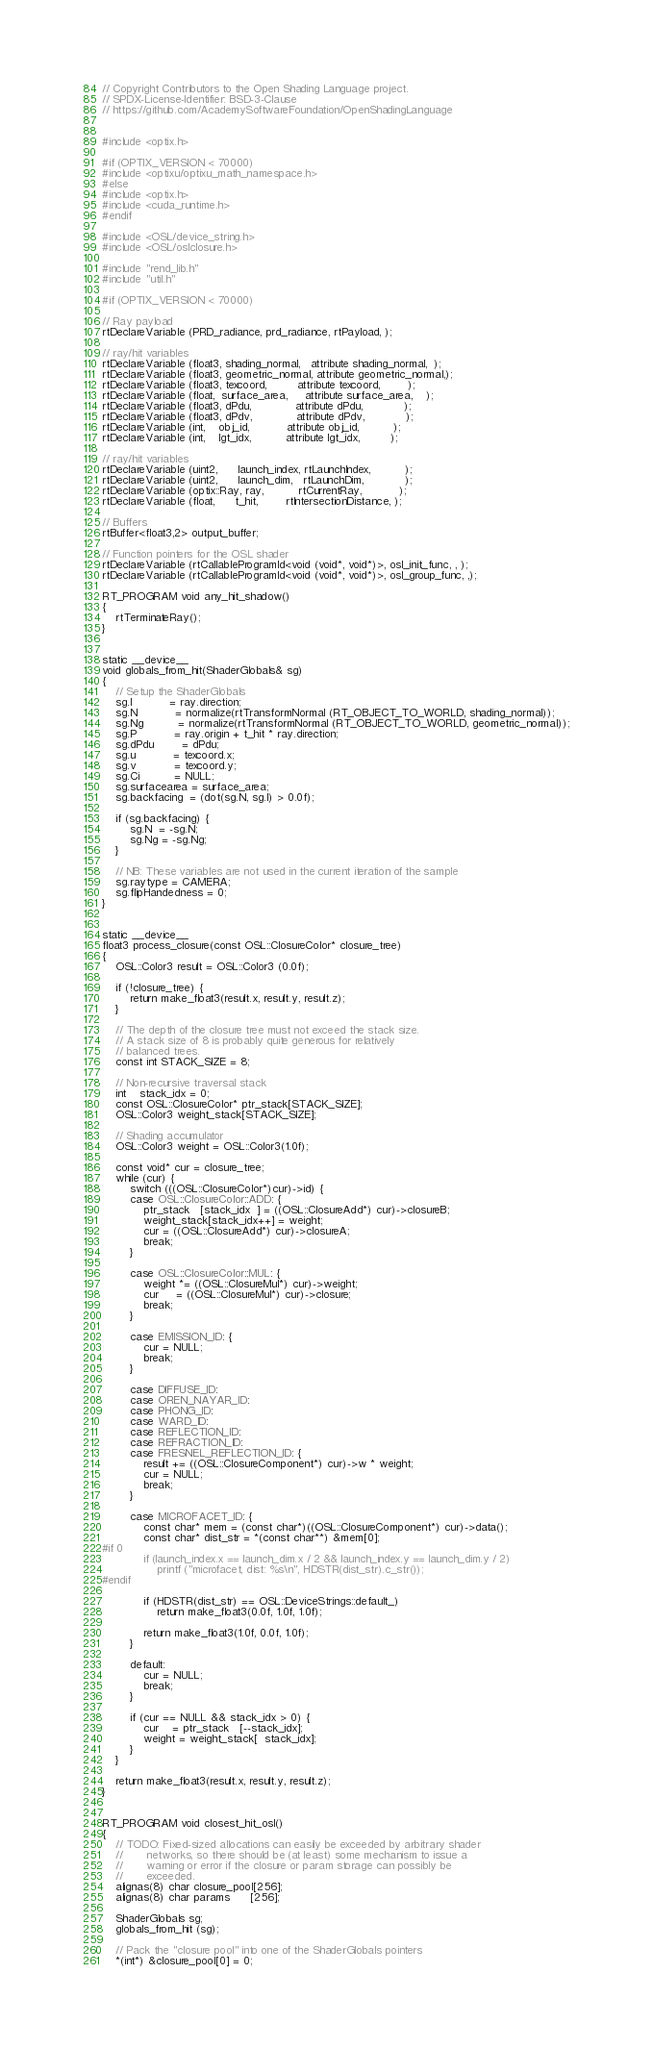<code> <loc_0><loc_0><loc_500><loc_500><_Cuda_>// Copyright Contributors to the Open Shading Language project.
// SPDX-License-Identifier: BSD-3-Clause
// https://github.com/AcademySoftwareFoundation/OpenShadingLanguage


#include <optix.h>

#if (OPTIX_VERSION < 70000) 
#include <optixu/optixu_math_namespace.h>
#else
#include <optix.h>
#include <cuda_runtime.h>
#endif

#include <OSL/device_string.h>
#include <OSL/oslclosure.h>

#include "rend_lib.h"
#include "util.h"

#if (OPTIX_VERSION < 70000)

// Ray payload
rtDeclareVariable (PRD_radiance, prd_radiance, rtPayload, );

// ray/hit variables
rtDeclareVariable (float3, shading_normal,   attribute shading_normal,  );
rtDeclareVariable (float3, geometric_normal, attribute geometric_normal,);
rtDeclareVariable (float3, texcoord,         attribute texcoord,        );
rtDeclareVariable (float,  surface_area,     attribute surface_area,    );
rtDeclareVariable (float3, dPdu,             attribute dPdu,            );
rtDeclareVariable (float3, dPdv,             attribute dPdv,            );
rtDeclareVariable (int,    obj_id,           attribute obj_id,          );
rtDeclareVariable (int,    lgt_idx,          attribute lgt_idx,         );

// ray/hit variables
rtDeclareVariable (uint2,      launch_index, rtLaunchIndex,          );
rtDeclareVariable (uint2,      launch_dim,   rtLaunchDim,            );
rtDeclareVariable (optix::Ray, ray,          rtCurrentRay,           );
rtDeclareVariable (float,      t_hit,        rtIntersectionDistance, );

// Buffers
rtBuffer<float3,2> output_buffer;

// Function pointers for the OSL shader
rtDeclareVariable (rtCallableProgramId<void (void*, void*)>, osl_init_func, , );
rtDeclareVariable (rtCallableProgramId<void (void*, void*)>, osl_group_func, ,);

RT_PROGRAM void any_hit_shadow()
{
    rtTerminateRay();
}


static __device__
void globals_from_hit(ShaderGlobals& sg)
{
    // Setup the ShaderGlobals
    sg.I           = ray.direction;
    sg.N           = normalize(rtTransformNormal (RT_OBJECT_TO_WORLD, shading_normal));
    sg.Ng          = normalize(rtTransformNormal (RT_OBJECT_TO_WORLD, geometric_normal));
    sg.P           = ray.origin + t_hit * ray.direction;
    sg.dPdu        = dPdu;
    sg.u           = texcoord.x;
    sg.v           = texcoord.y;
    sg.Ci          = NULL;
    sg.surfacearea = surface_area;
    sg.backfacing  = (dot(sg.N, sg.I) > 0.0f);

    if (sg.backfacing) {
        sg.N  = -sg.N;
        sg.Ng = -sg.Ng;
    }

    // NB: These variables are not used in the current iteration of the sample
    sg.raytype = CAMERA;
    sg.flipHandedness = 0;
}


static __device__
float3 process_closure(const OSL::ClosureColor* closure_tree)
{
    OSL::Color3 result = OSL::Color3 (0.0f);

    if (!closure_tree) {
        return make_float3(result.x, result.y, result.z);
    }

    // The depth of the closure tree must not exceed the stack size.
    // A stack size of 8 is probably quite generous for relatively
    // balanced trees.
    const int STACK_SIZE = 8;

    // Non-recursive traversal stack
    int    stack_idx = 0;
    const OSL::ClosureColor* ptr_stack[STACK_SIZE];
    OSL::Color3 weight_stack[STACK_SIZE];

    // Shading accumulator
    OSL::Color3 weight = OSL::Color3(1.0f);

    const void* cur = closure_tree;
    while (cur) {
        switch (((OSL::ClosureColor*)cur)->id) {
        case OSL::ClosureColor::ADD: {
            ptr_stack   [stack_idx  ] = ((OSL::ClosureAdd*) cur)->closureB;
            weight_stack[stack_idx++] = weight;
            cur = ((OSL::ClosureAdd*) cur)->closureA;
            break;
        }

        case OSL::ClosureColor::MUL: {
            weight *= ((OSL::ClosureMul*) cur)->weight;
            cur     = ((OSL::ClosureMul*) cur)->closure;
            break;
        }

        case EMISSION_ID: {
            cur = NULL;
            break;
        }

        case DIFFUSE_ID:
        case OREN_NAYAR_ID:
        case PHONG_ID:
        case WARD_ID:
        case REFLECTION_ID:
        case REFRACTION_ID:
        case FRESNEL_REFLECTION_ID: {
            result += ((OSL::ClosureComponent*) cur)->w * weight;
            cur = NULL;
            break;
        }

        case MICROFACET_ID: {
            const char* mem = (const char*)((OSL::ClosureComponent*) cur)->data();
            const char* dist_str = *(const char**) &mem[0];
#if 0
            if (launch_index.x == launch_dim.x / 2 && launch_index.y == launch_dim.y / 2)
                printf ("microfacet, dist: %s\n", HDSTR(dist_str).c_str());
#endif

            if (HDSTR(dist_str) == OSL::DeviceStrings::default_)
                return make_float3(0.0f, 1.0f, 1.0f);

            return make_float3(1.0f, 0.0f, 1.0f);
        }

        default:
            cur = NULL;
            break;
        }

        if (cur == NULL && stack_idx > 0) {
            cur    = ptr_stack   [--stack_idx];
            weight = weight_stack[  stack_idx];
        }
    }

    return make_float3(result.x, result.y, result.z);
}


RT_PROGRAM void closest_hit_osl()
{
    // TODO: Fixed-sized allocations can easily be exceeded by arbitrary shader
    //       networks, so there should be (at least) some mechanism to issue a
    //       warning or error if the closure or param storage can possibly be
    //       exceeded.
    alignas(8) char closure_pool[256];
    alignas(8) char params      [256];

    ShaderGlobals sg;
    globals_from_hit (sg);

    // Pack the "closure pool" into one of the ShaderGlobals pointers
    *(int*) &closure_pool[0] = 0;</code> 